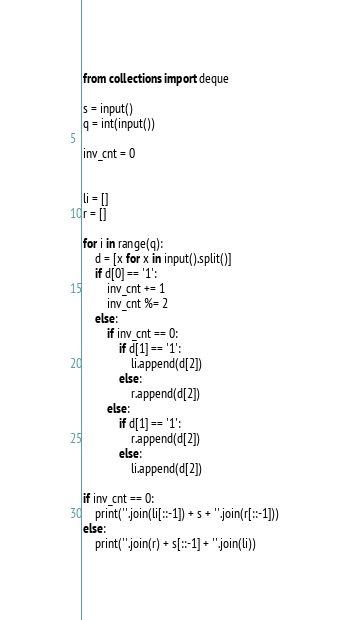Convert code to text. <code><loc_0><loc_0><loc_500><loc_500><_Python_>from collections import deque

s = input()
q = int(input())

inv_cnt = 0


li = []
r = []

for i in range(q):
    d = [x for x in input().split()]
    if d[0] == '1':
        inv_cnt += 1
        inv_cnt %= 2
    else:
        if inv_cnt == 0:
            if d[1] == '1':
                li.append(d[2])
            else:
                r.append(d[2])
        else:
            if d[1] == '1':
                r.append(d[2])
            else:
                li.append(d[2])

if inv_cnt == 0:
    print(''.join(li[::-1]) + s + ''.join(r[::-1]))
else:
    print(''.join(r) + s[::-1] + ''.join(li))
</code> 